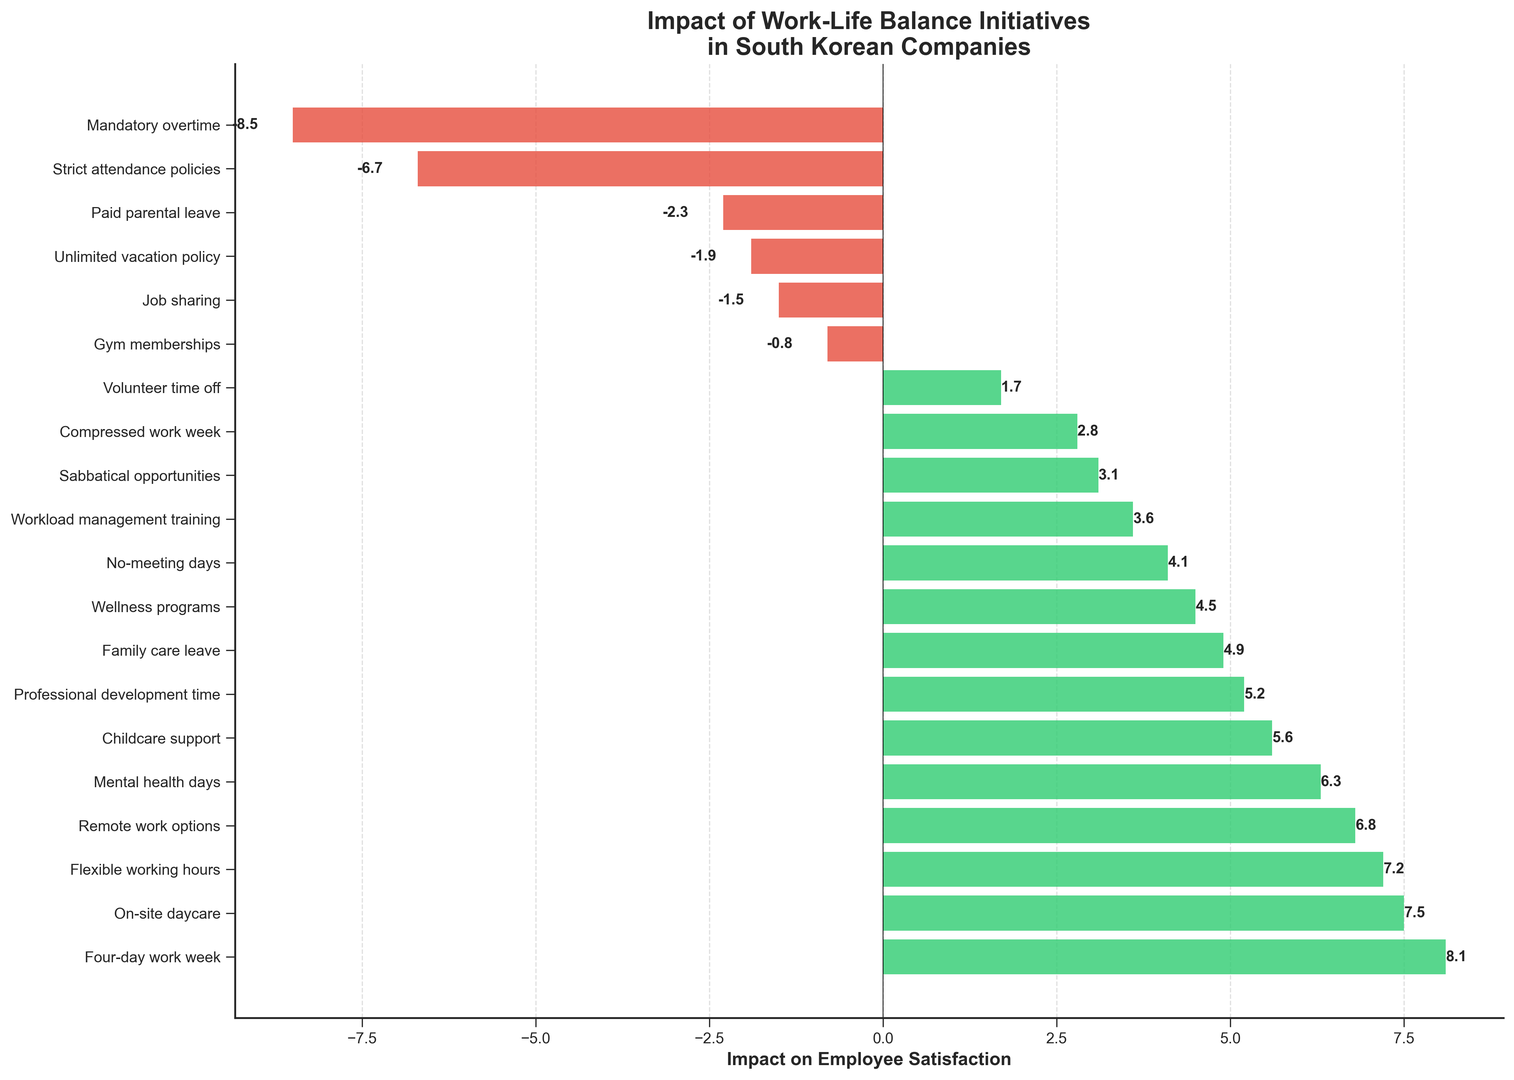Which initiative has the highest positive impact on employee satisfaction? The highest bar on the right side of the center line represents the initiative with the highest positive impact. The bar labeled "Four-day work week" is the longest positive bar.
Answer: Four-day work week Which initiative has the most negative impact on employee satisfaction? The lowest bar on the left side of the center line represents the initiative with the most negative impact. The bar labeled "Mandatory overtime" is the longest negative bar.
Answer: Mandatory overtime How many initiatives have a positive impact on employee satisfaction? Count the bars extending to the right of the center line (positive values). There are 14 bars in total that indicate a positive impact.
Answer: 14 How many initiatives have a negative impact on employee satisfaction? Count the bars extending to the left of the center line (negative values). There are 6 bars indicating a negative impact.
Answer: 6 What is the combined impact value of the initiatives with negative impact? Add the impact values of the initiatives with negative impact (Paid parental leave, Unlimited vacation policy, Job sharing, Gym memberships, Mandatory overtime, Strict attendance policies). The combined value is -2.3 + -1.9 + -1.5 + -0.8 + -8.5 + -6.7 = -21.7.
Answer: -21.7 Which initiatives have an impact value less than -2? Look for bars on the left side of the center line that extend beyond the -2 mark. These initiatives are "Paid parental leave", "Unlimited vacation policy", "Mandatory overtime", and "Strict attendance policies".
Answer: Paid parental leave, Unlimited vacation policy, Mandatory overtime, Strict attendance policies What's the difference in impact between "Flexible working hours" and "Gym memberships"? The impact of "Flexible working hours" is 7.2 and for "Gym memberships" is -0.8. The difference is 7.2 - (-0.8) = 7.2 + 0.8 = 8.0.
Answer: 8.0 What is the average impact value of the top 5 positive initiatives? Identify the top 5 initiatives with the highest impact values: Four-day work week (8.1), On-site daycare (7.5), Flexible working hours (7.2), Remote work options (6.8), and Mental health days (6.3). Calculate the average: (8.1 + 7.5 + 7.2 + 6.8 + 6.3) / 5 = 35.9 / 5 = 7.18.
Answer: 7.18 What is the total impact value of initiatives related to childcare (On-site daycare, Childcare support, Family care leave)? Add the impact values of "On-site daycare" (7.5), "Childcare support" (5.6), and "Family care leave" (4.9). The total is 7.5 + 5.6 + 4.9 = 18.0.
Answer: 18.0 